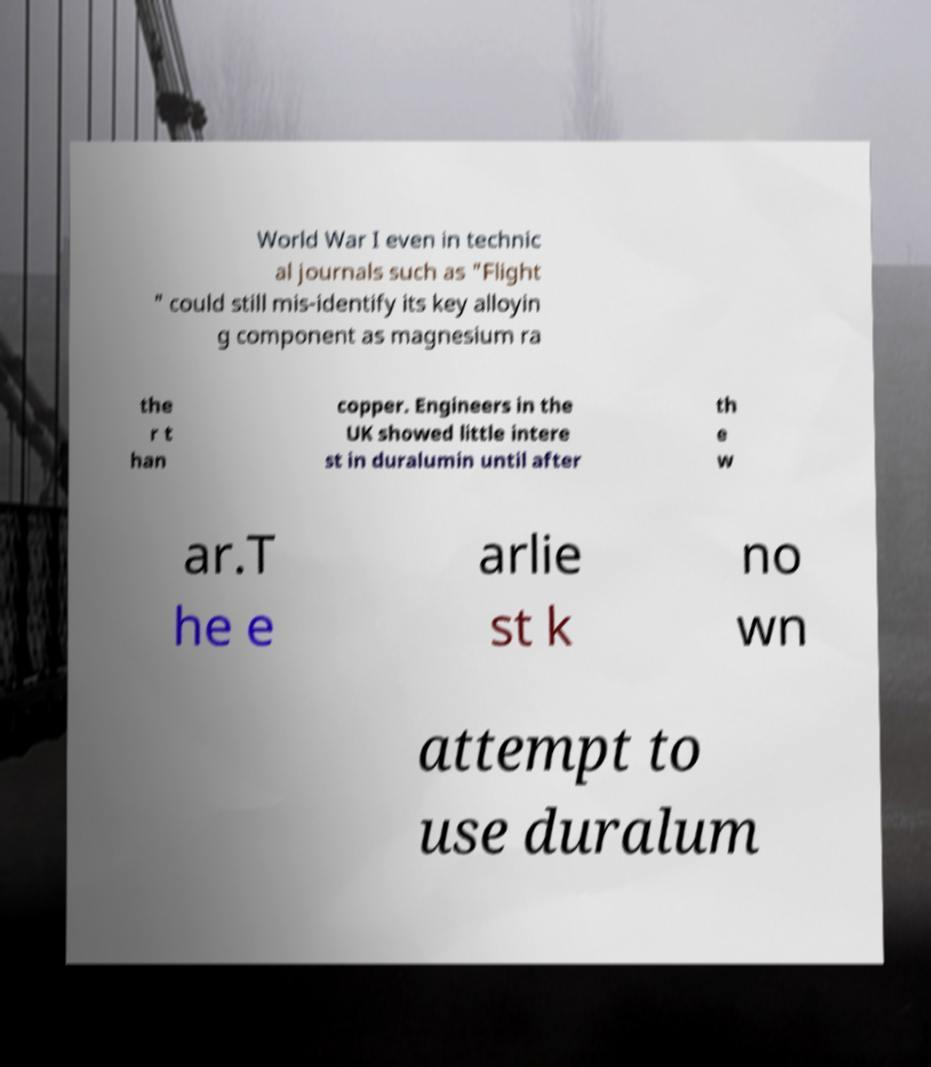Please identify and transcribe the text found in this image. World War I even in technic al journals such as "Flight " could still mis-identify its key alloyin g component as magnesium ra the r t han copper. Engineers in the UK showed little intere st in duralumin until after th e w ar.T he e arlie st k no wn attempt to use duralum 